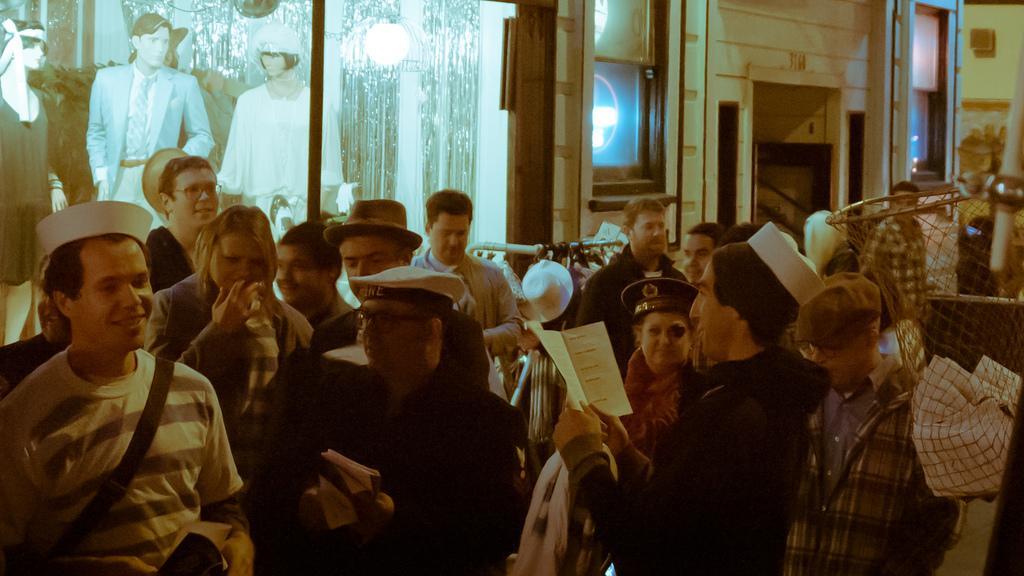In one or two sentences, can you explain what this image depicts? In this picture, we see group of people are standing. The man in the middle of the picture wearing a black jacket is holding a book in his hands. Behind them, we see a stand. On the right side, we see a net basket in which white cloth is placed. On the left side, the mannequins are displayed. Beside that, we see a wall. In the background, we see the entrance to the room. 